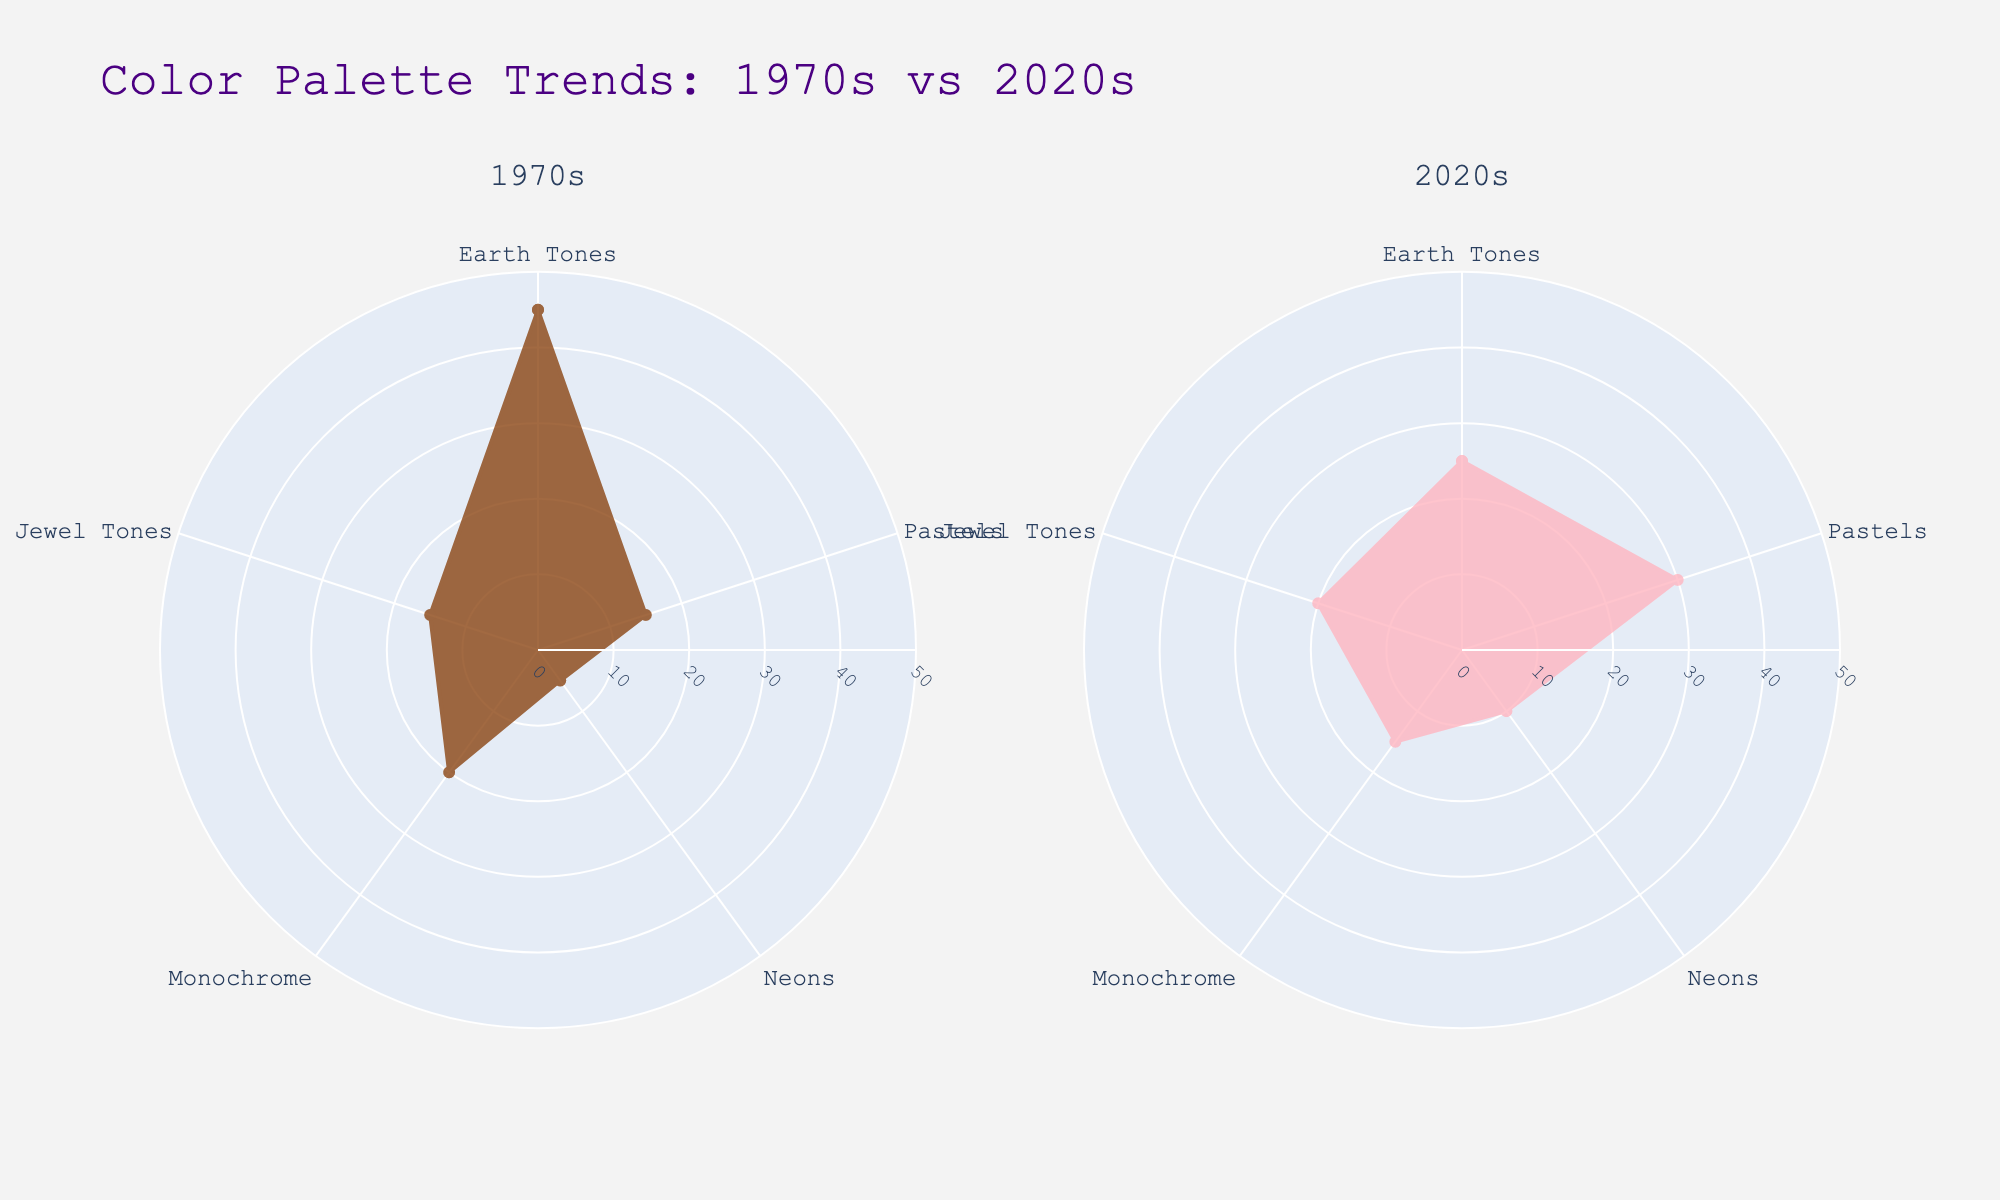What are the two decades compared in the figure? The figure's subplot titles depict two different decades. On the left, we have the 1970s, and on the right, the 2020s.
Answer: 1970s and 2020s Which color palette is most prominent in the 1970s runway collections? Viewing the 1970s subplot, the Earth Tones category reaches the highest radial distance compared to others (45 units).
Answer: Earth Tones How has the use of Pastels changed from the 1970s to the 2020s? In the 1970s subplot, Pastels have a value of 15, whereas in the 2020s subplot, Pastels' value is 30. The usage has increased.
Answer: Increased Which color palette shows the least difference in usage between the 1970s and the 2020s? Comparing both subplots, Monochrome shows minimal difference, with values of 20 in the 1970s and 15 in the 2020s, a change of only 5 units.
Answer: Monochrome What is the combined frequency of Jewel Tones and Neons in the 2020s? On the 2020s subplot, the Jewel Tones have a value of 20 and Neons have a value of 10. Combined, their frequency is 20 + 10 = 30.
Answer: 30 Which decade shows a greater use of color palettes that have a frequency below 20? Decades with frequencies below 20 for pastels include 'Neons' with 5 and 'Pastels' with 15 for the 1970s, and 'Monochrome' with 15 and 'Neons' with 10 in the 2020s. Totals: 20 units (1970s) and 25 units (2020s).
Answer: 2020s By how many units did the frequency of Earth Tones decrease from the 1970s to the 2020s? Earth Tones in the 1970s are at 45 units, while in the 2020s, they are at 25 units. The decrease is 45 - 25 = 20 units.
Answer: 20 units Which color palette has seen the biggest increase from the 1970s to the 2020s? Comparing both subplots, Pastels increased from 15 units (1970s) to 30 units (2020s), showing the biggest increase of 30-15 = 15 units.
Answer: Pastels 